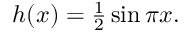<formula> <loc_0><loc_0><loc_500><loc_500>\begin{array} { r } { h ( x ) = \frac { 1 } { 2 } \sin \pi x . } \end{array}</formula> 